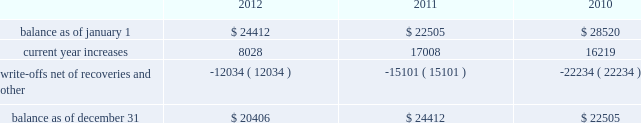American tower corporation and subsidiaries notes to consolidated financial statements when they are determined uncollectible .
Such determination includes analysis and consideration of the particular conditions of the account .
Changes in the allowances were as follows for the years ended december 31 , ( in thousands ) : .
Functional currency 2014as a result of changes to the organizational structure of the company 2019s subsidiaries in latin america in 2010 , the company determined that effective january 1 , 2010 , the functional currency of its foreign subsidiary in brazil is the brazilian real .
From that point forward , all assets and liabilities held by the subsidiary in brazil are translated into u.s .
Dollars at the exchange rate in effect at the end of the applicable reporting period .
Revenues and expenses are translated at the average monthly exchange rates and the cumulative translation effect is included in equity .
The change in functional currency from u.s .
Dollars to brazilian real gave rise to an increase in the net value of certain non-monetary assets and liabilities .
The aggregate impact on such assets and liabilities was $ 39.8 million with an offsetting increase in accumulated other comprehensive income during the year ended december 31 , 2010 .
As a result of the renegotiation of the company 2019s agreements with grupo iusacell , s.a .
De c.v .
( 201ciusacell 201d ) , which included , among other changes , converting iusacell 2019s contractual obligations to the company from u.s .
Dollars to mexican pesos , the company determined that effective april 1 , 2010 , the functional currency of certain of its foreign subsidiaries in mexico is the mexican peso .
From that point forward , all assets and liabilities held by those subsidiaries in mexico are translated into u.s .
Dollars at the exchange rate in effect at the end of the applicable reporting period .
Revenues and expenses are translated at the average monthly exchange rates and the cumulative translation effect is included in equity .
The change in functional currency from u.s .
Dollars to mexican pesos gave rise to a decrease in the net value of certain non-monetary assets and liabilities .
The aggregate impact on such assets and liabilities was $ 33.6 million with an offsetting decrease in accumulated other comprehensive income .
The functional currency of the company 2019s other foreign operating subsidiaries is also the respective local currency .
All assets and liabilities held by the subsidiaries are translated into u.s .
Dollars at the exchange rate in effect at the end of the applicable fiscal reporting period .
Revenues and expenses are translated at the average monthly exchange rates .
The cumulative translation effect is included in equity as a component of accumulated other comprehensive income .
Foreign currency transaction gains and losses are recognized in the consolidated statements of operations and are the result of transactions of a subsidiary being denominated in a currency other than its functional currency .
Cash and cash equivalents 2014cash and cash equivalents include cash on hand , demand deposits and short-term investments , including money market funds , with remaining maturities of three months or less when acquired , whose cost approximates fair value .
Restricted cash 2014the company classifies as restricted cash all cash pledged as collateral to secure obligations and all cash whose use is otherwise limited by contractual provisions , including cash on deposit in reserve accounts relating to the commercial mortgage pass-through certificates , series 2007-1 issued in the company 2019s securitization transaction and the secured cellular site revenue notes , series 2010-1 class c , series 2010-2 class c and series 2010-2 class f , assumed by the company as a result of the acquisition of certain legal entities from unison holdings , llc and unison site management ii , l.l.c .
( collectively , 201cunison 201d ) . .
What was the average bad debt allowance for the past three years , in billions? 
Computations: table_average(balance as of december 31, none)
Answer: 22441.0. 